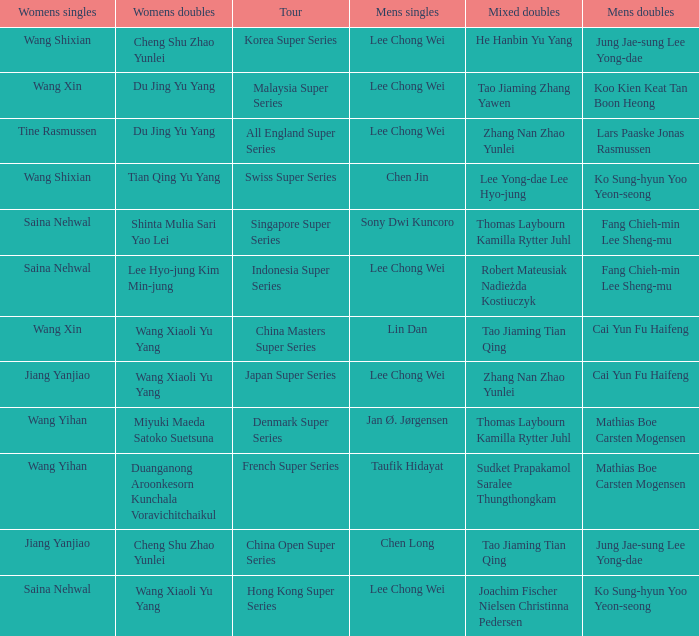Who were the womens doubles when the mixed doubles were zhang nan zhao yunlei on the tour all england super series? Du Jing Yu Yang. 